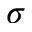Convert formula to latex. <formula><loc_0><loc_0><loc_500><loc_500>\sigma</formula> 